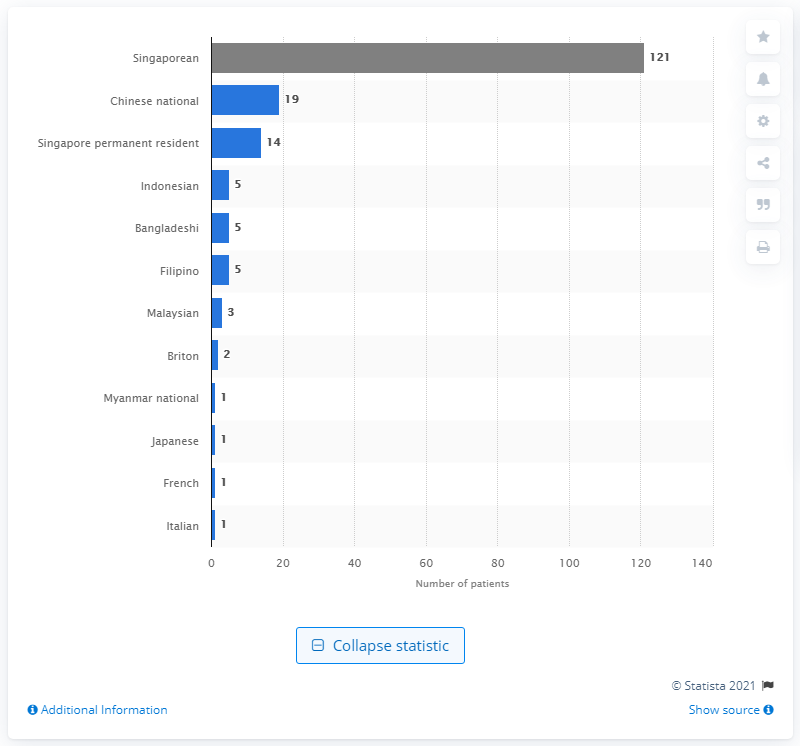Mention a couple of crucial points in this snapshot. There were 121 COVID-19 patients who were Singaporean in total. 